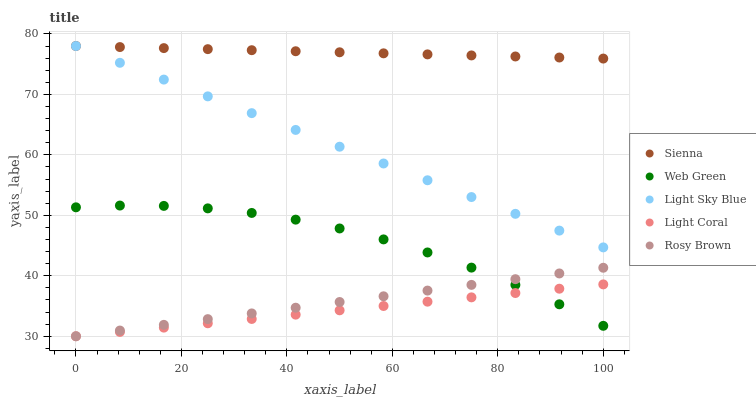Does Light Coral have the minimum area under the curve?
Answer yes or no. Yes. Does Sienna have the maximum area under the curve?
Answer yes or no. Yes. Does Rosy Brown have the minimum area under the curve?
Answer yes or no. No. Does Rosy Brown have the maximum area under the curve?
Answer yes or no. No. Is Rosy Brown the smoothest?
Answer yes or no. Yes. Is Web Green the roughest?
Answer yes or no. Yes. Is Light Coral the smoothest?
Answer yes or no. No. Is Light Coral the roughest?
Answer yes or no. No. Does Light Coral have the lowest value?
Answer yes or no. Yes. Does Light Sky Blue have the lowest value?
Answer yes or no. No. Does Light Sky Blue have the highest value?
Answer yes or no. Yes. Does Rosy Brown have the highest value?
Answer yes or no. No. Is Light Coral less than Sienna?
Answer yes or no. Yes. Is Light Sky Blue greater than Light Coral?
Answer yes or no. Yes. Does Web Green intersect Rosy Brown?
Answer yes or no. Yes. Is Web Green less than Rosy Brown?
Answer yes or no. No. Is Web Green greater than Rosy Brown?
Answer yes or no. No. Does Light Coral intersect Sienna?
Answer yes or no. No. 